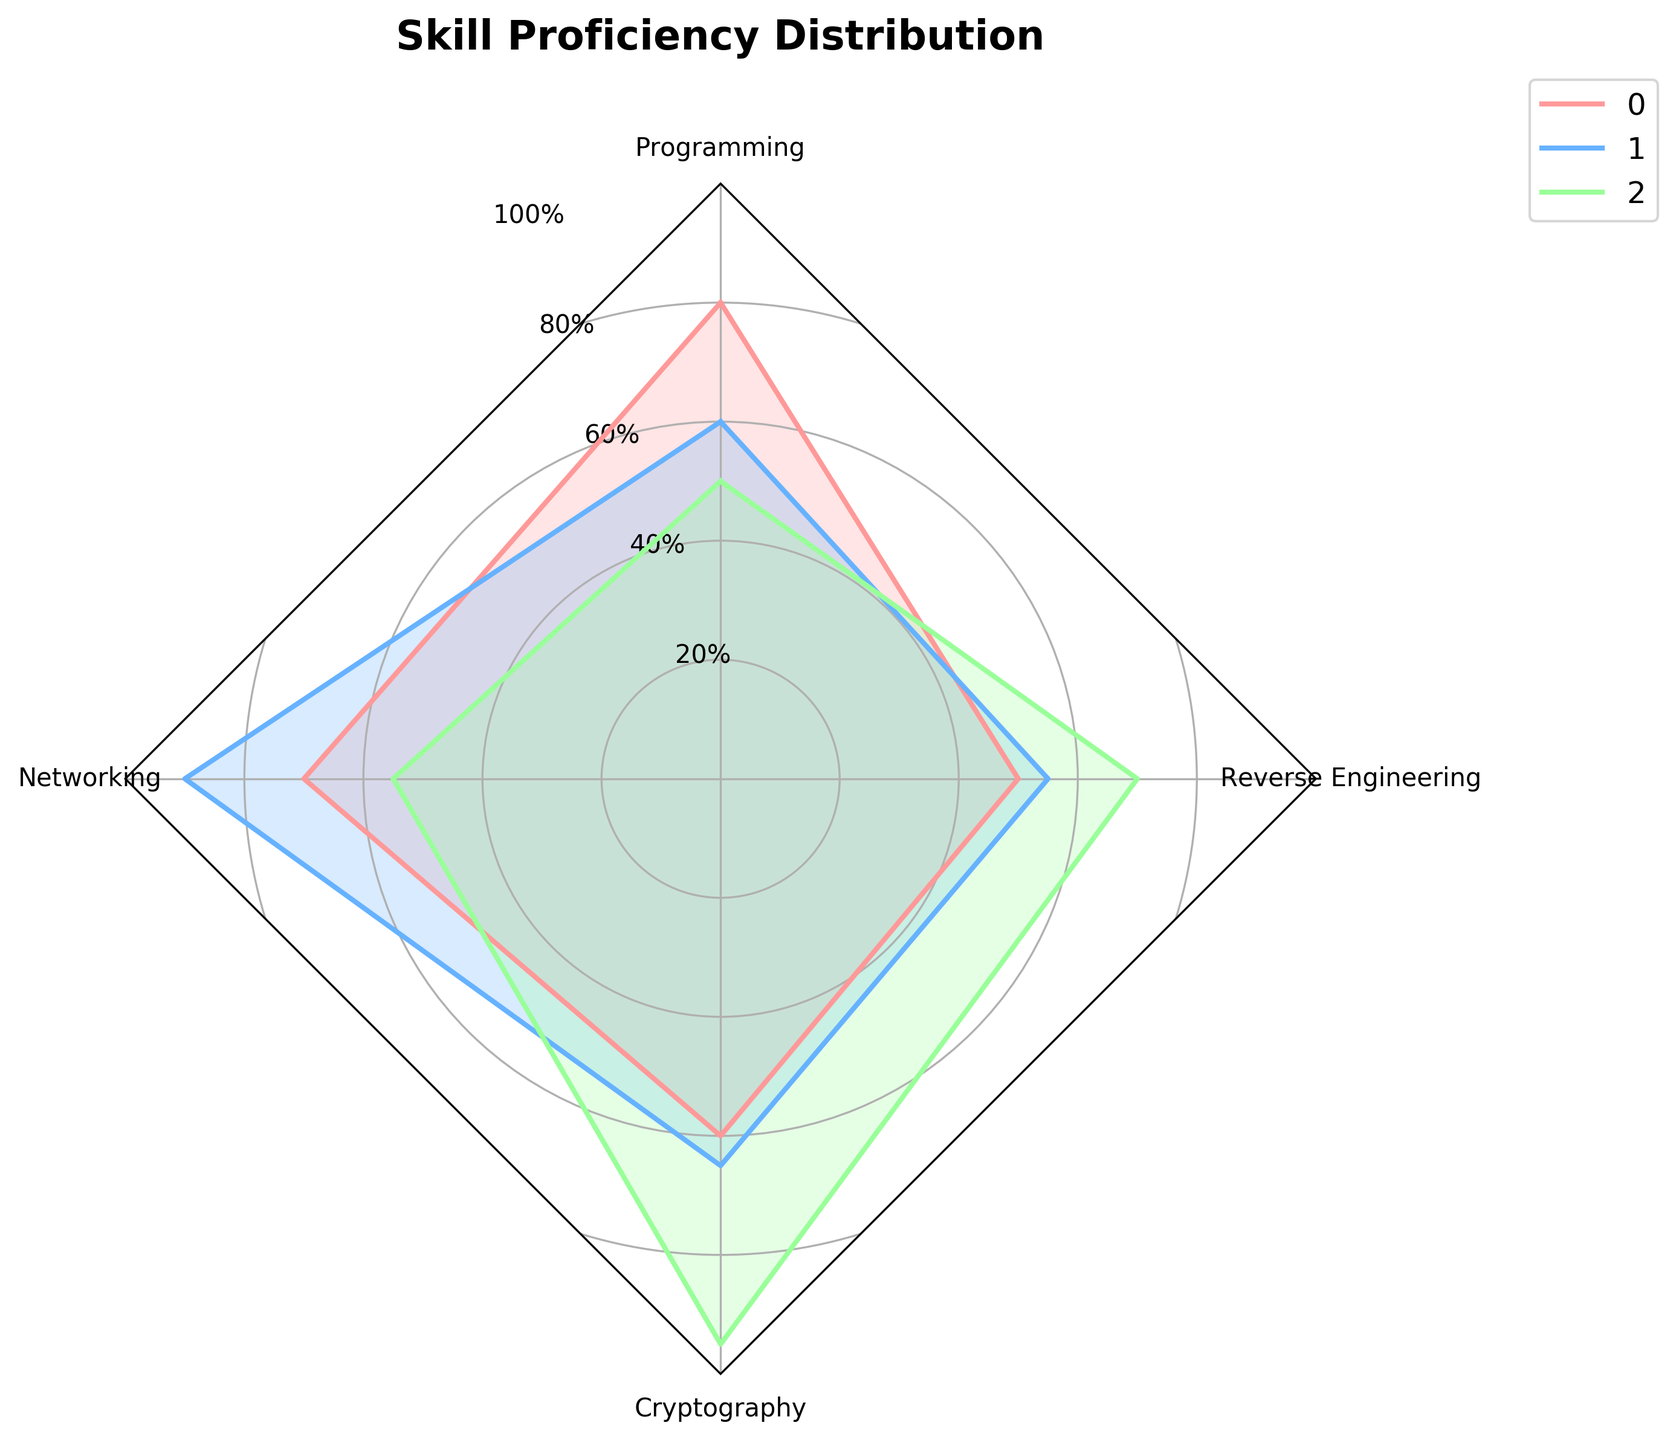What's the title of the figure? The title is located at the top of the radar chart, usually displayed in bold for emphasis. Here, it is written as "Skill Proficiency Distribution".
Answer: Skill Proficiency Distribution How many areas are being analyzed? By inspecting the labels on the legend, you can see that there are three areas mentioned: Web Application Testing, Network Security, and Cryptanalysis.
Answer: 3 Which area shows the highest proficiency in Cryptography? By observing the values spread out towards the Cryptography axis, Cryptanalysis has the furthest extension towards 95%, indicating the highest proficiency.
Answer: Cryptanalysis Compare the proficiency levels of Web Application Testing and Network Security in Programming. Which is higher? Look at the lines extending towards Programming for both areas. Web Application Testing reaches 80%, while Network Security reaches only 60%.
Answer: Web Application Testing What is the average proficiency of Network Security across all the skills? Sum the proficiency values for Network Security (60 + 90 + 65 + 55) and divide by the number of skills (4). The calculation is (60 + 90 + 65 + 55) / 4 = 67.5%.
Answer: 67.5% Which area demonstrates the least proficiency in Reverse Engineering? By examining the lines extending towards the Reverse Engineering axis, Web Application Testing reaches only 50%, which is the shortest compared to the other areas.
Answer: Web Application Testing Rank the areas based on their proficiency in Networking from highest to lowest. By examining the points towards the Networking axis, Network Security is at 90%, followed by Web Application Testing at 70%, and Cryptanalysis at 55%.
Answer: Network Security, Web Application Testing, Cryptanalysis Is the proficiency in Programming for Network Security higher than in Reverse Engineering for the same area? Network Security reaches 60% in Programming and 55% in Reverse Engineering. Comparing both values, 60% is higher than 55%.
Answer: Yes Is there any skill where all three areas have proficiency above 50%? Check each axis to see where all values are above 50%. Each area has values above 50% in Programming, so this condition is satisfied for the programming skill.
Answer: Yes, in Programming Which area has the most balanced proficiency across all skills? To determine balance, the proficiency levels should be close to each other across all skills. Web Application Testing has the closest range, with values from 50% to 80%, compared to other areas with more significant variances.
Answer: Web Application Testing 